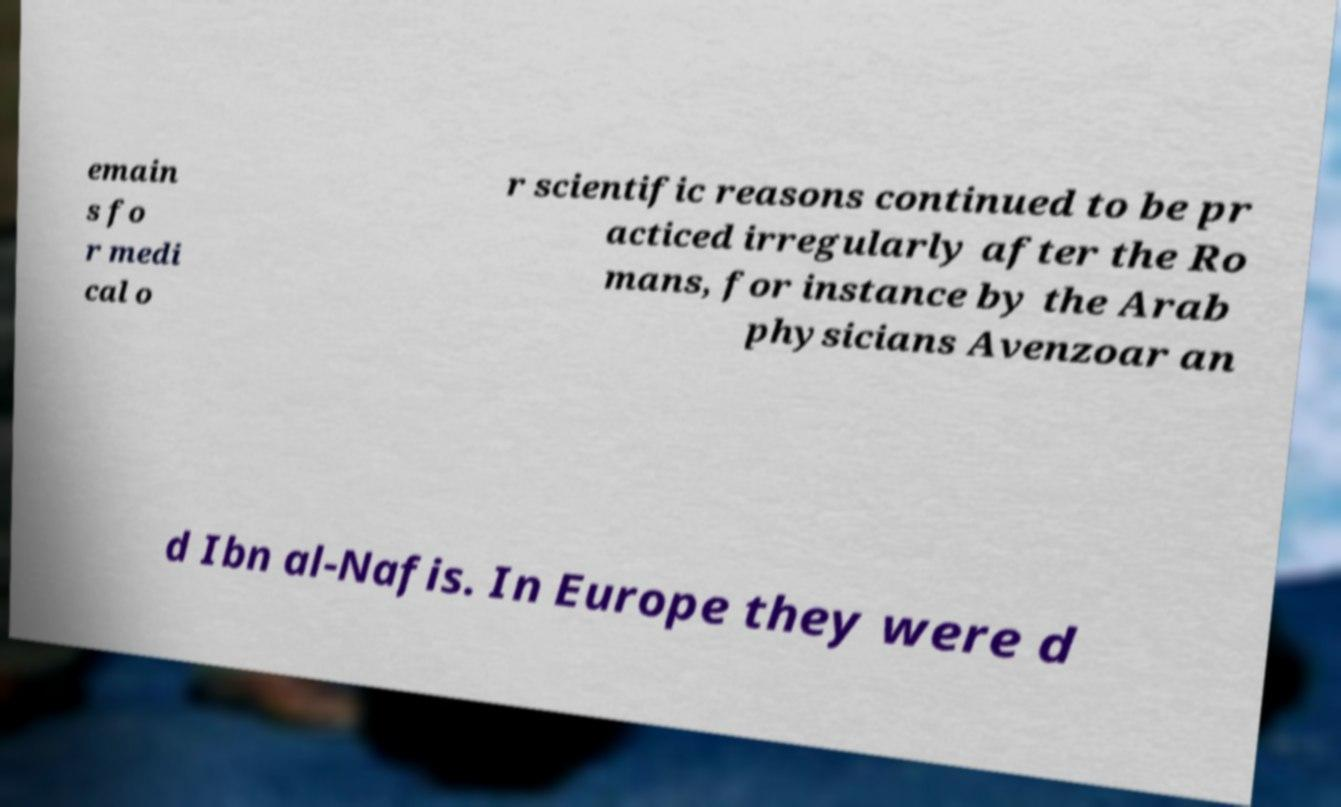There's text embedded in this image that I need extracted. Can you transcribe it verbatim? emain s fo r medi cal o r scientific reasons continued to be pr acticed irregularly after the Ro mans, for instance by the Arab physicians Avenzoar an d Ibn al-Nafis. In Europe they were d 